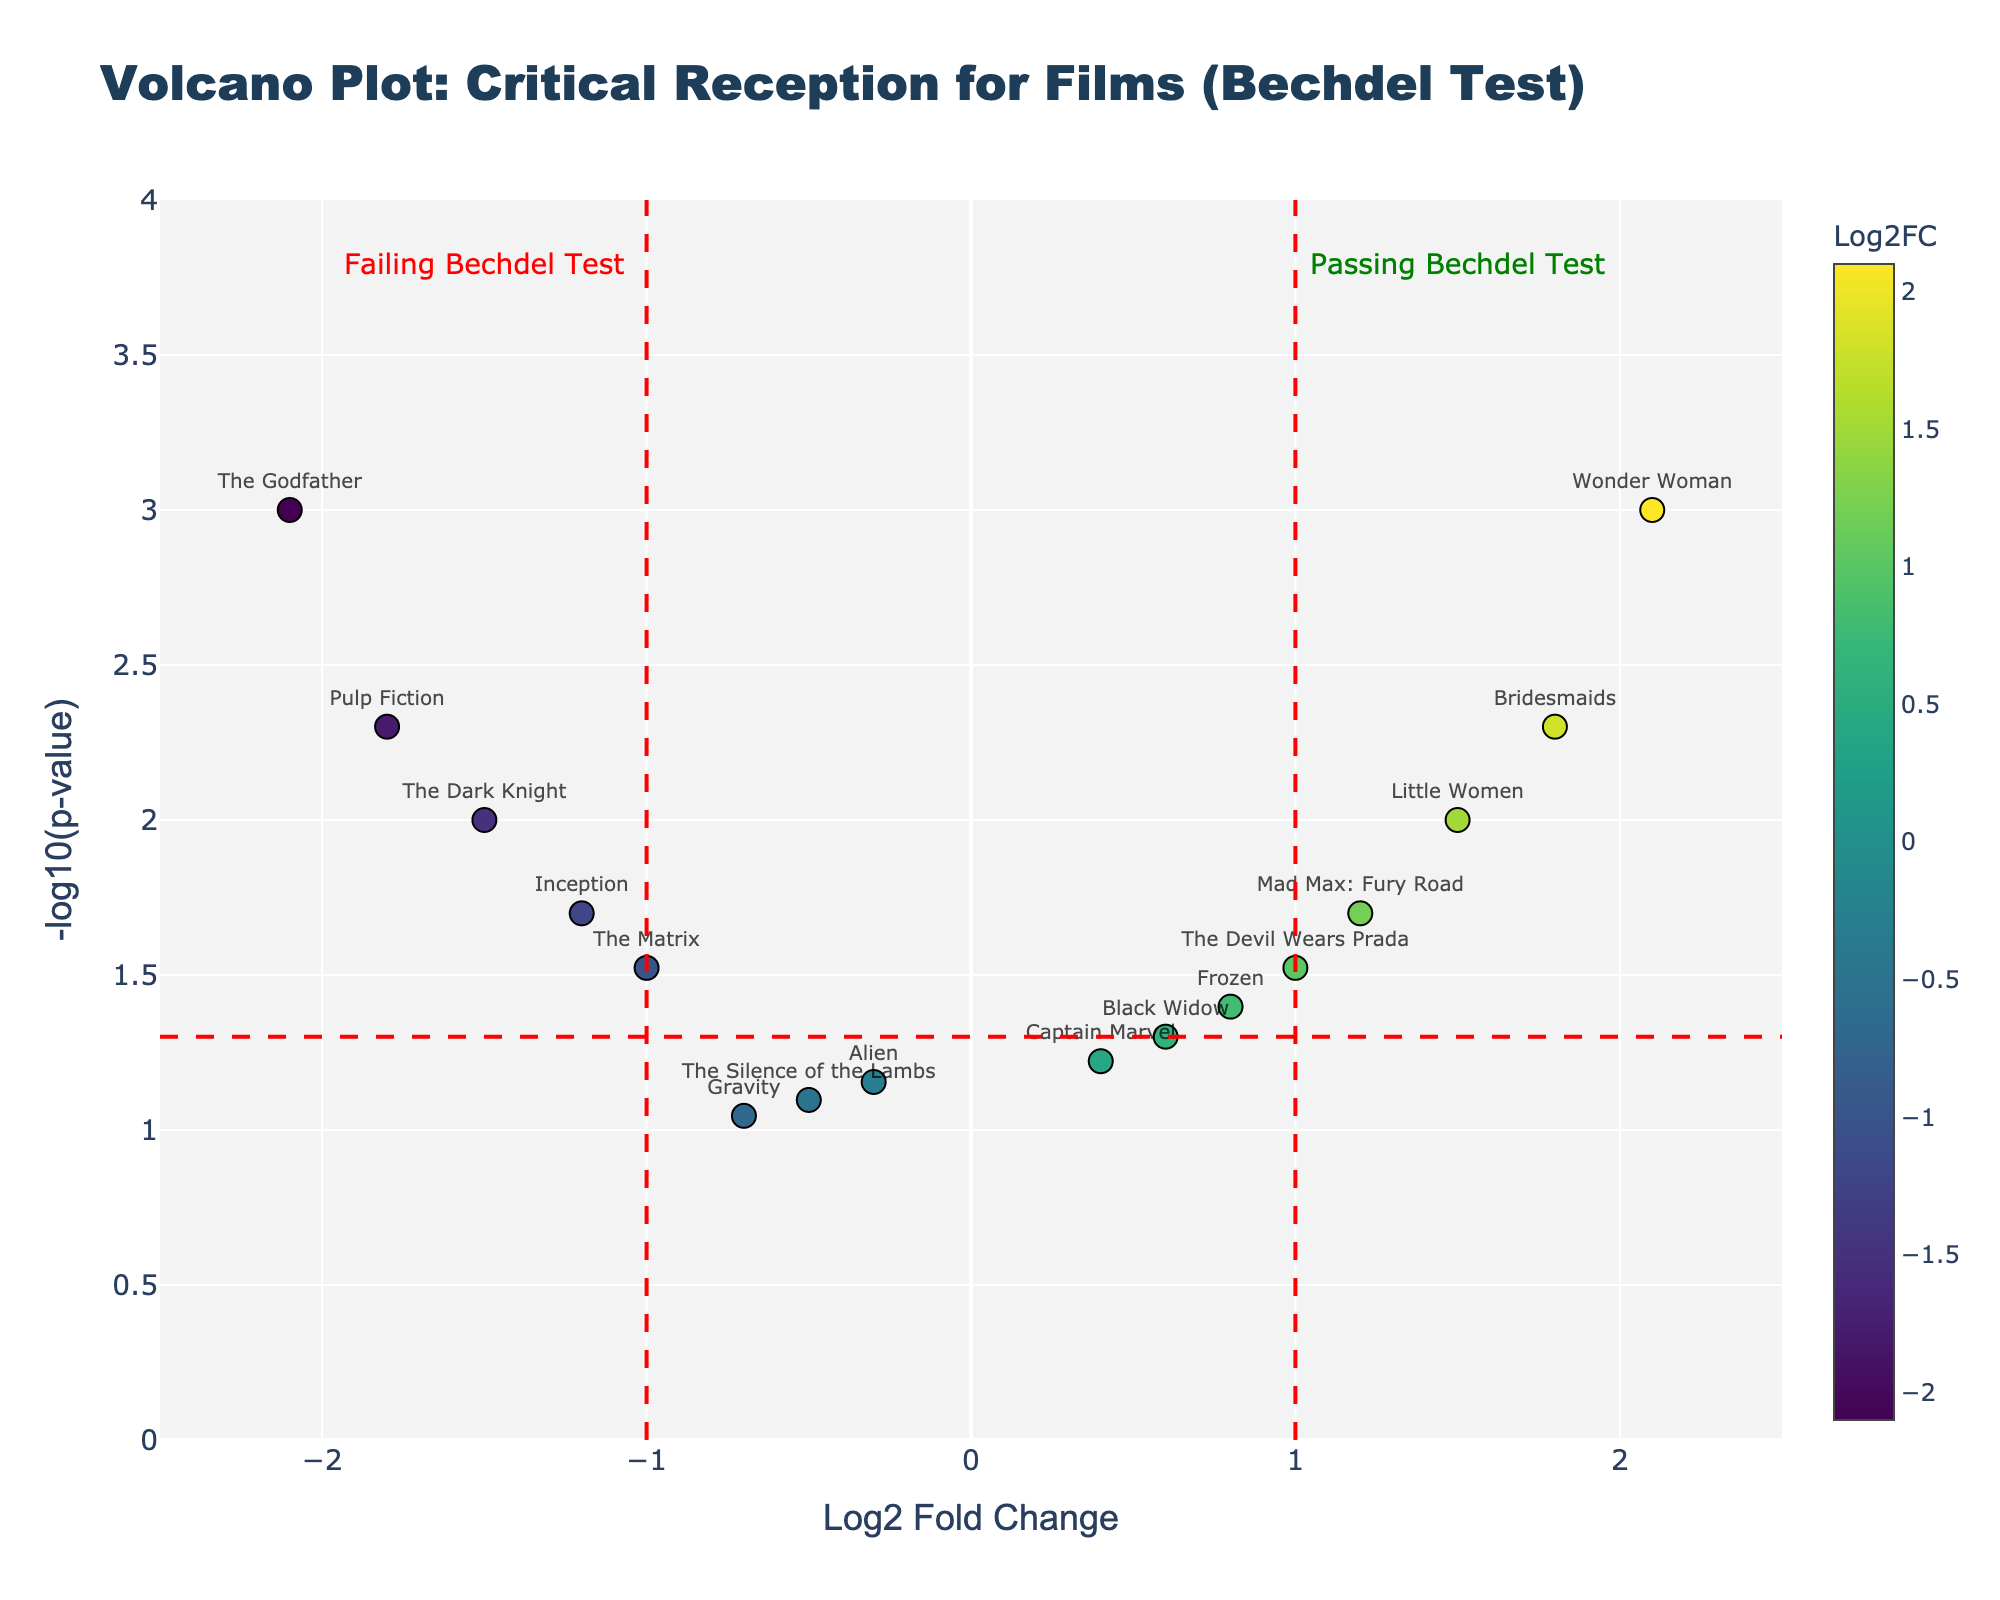What is the main title of the volcano plot? The main title can be observed at the top of the plot and highlights the overall context. Looking at the top of the figure, we see the title "Volcano Plot: Critical Reception for Films (Bechdel Test)".
Answer: Volcano Plot: Critical Reception for Films (Bechdel Test) How many movies are plotted in the figure? We need to count the number of data points displayed in the plot. Each point represents a movie; counting them gives us a total of 16.
Answer: 16 Which movie passing the Bechdel Test has the highest Log2 Fold Change (Log2FC)? To find this, we look for the highest positive Log2FC value among the movies that pass the Bechdel Test. The highest value is for "Wonder Woman" with a Log2FC of 2.1.
Answer: Wonder Woman What is the significance threshold for the P-value in the plot? Significance is usually denoted by a horizontal dashed red line. The P-value threshold is shown as -log10(p-value) = 1.3 (since -log10(0.05) ≈ 1.3).
Answer: 0.05 Which movie that failed the Bechdel Test has the lowest Log2 Fold Change? We need to find the movie with the most negative Log2FC among the ones below the P-value threshold. "The Godfather" has the lowest Log2FC of -2.1.
Answer: The Godfather Are there more movies that pass the Bechdel Test or fail it? Movies that pass the Bechdel Test are on the right side (Log2FC > 0), and those that fail are on the left (Log2FC < 0). Counting both sides, there are 7 movies passing and 9 failing.
Answer: Fail it Which movie with a Log2FC greater than 1 has the highest -log10(p-value)? We look at movies with Log2FC > 1 and compare their -log10(p-value). "Wonder Woman" has the highest value of -log10(p-value) = 3.
Answer: Wonder Woman How does "The Matrix" compare to "Wonder Woman" in terms of Log2FC and p-value? Comparing positions on the plot, "The Matrix" has a Log2FC of -1.0 and a p-value slightly less significant, while "Wonder Woman" has Log2FC = 2.1 and more significant p-value.
Answer: "Wonder Woman" has higher Log2FC and more significant p-value Which range of Log2FC values is highlighted with vertical dashed lines? The vertical red dashed lines indicate the threshold for Log2FC values. They typically highlight regions of Log2FC = -1 and Log2FC = 1.
Answer: Between -1 and 1 What does the color scale represent in the plot? The color of each point represents the Log2FC value of each movie, as indicated by the color bar on the right side of the plot.
Answer: Log2 Fold Change (Log2FC) 